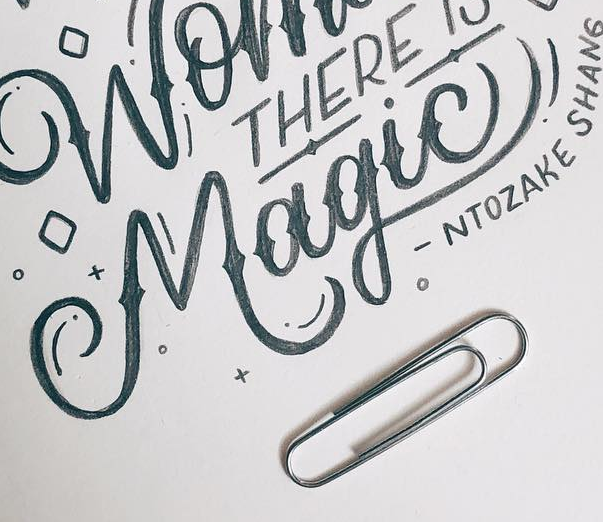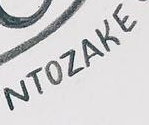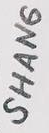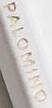Transcribe the words shown in these images in order, separated by a semicolon. Magic!; NTOZAKE; SHANG; PALOMINO 